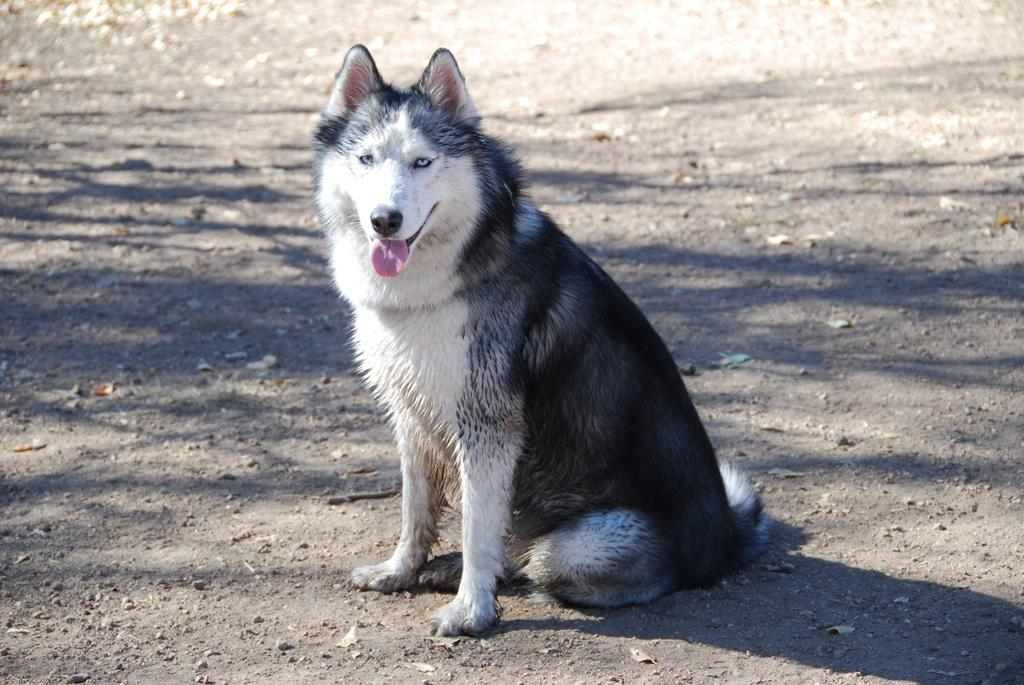What animal can be seen in the image? There is a dog in the image. What is the dog doing in the image? The dog is sitting on the ground. What part of the news can be seen in the image? There is no news present in the image; it features a dog sitting on the ground. 